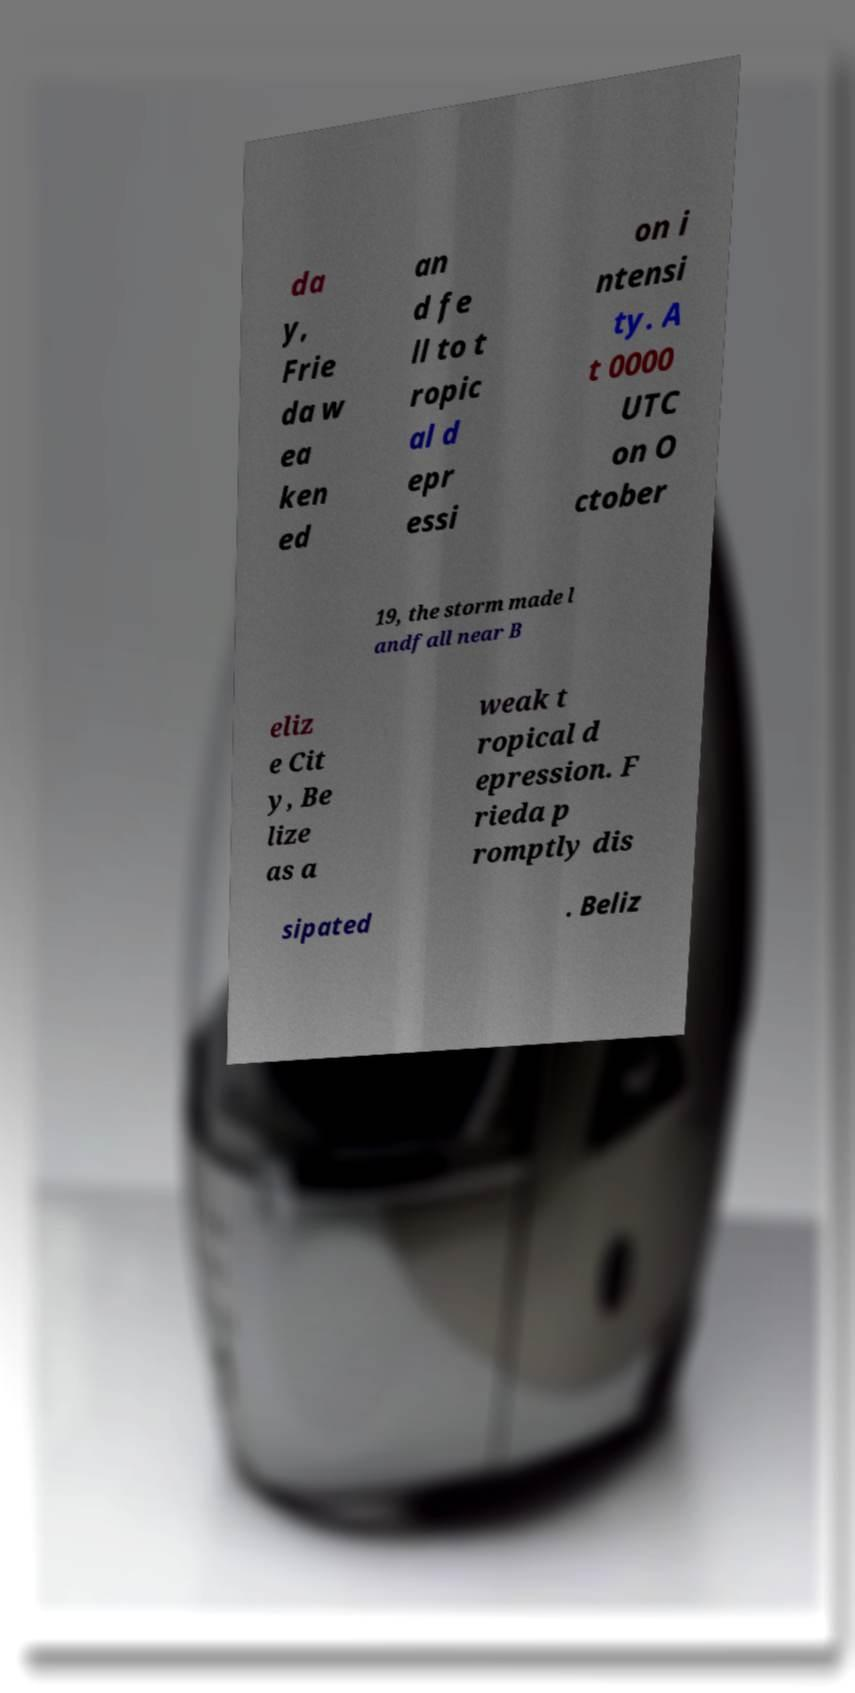I need the written content from this picture converted into text. Can you do that? da y, Frie da w ea ken ed an d fe ll to t ropic al d epr essi on i ntensi ty. A t 0000 UTC on O ctober 19, the storm made l andfall near B eliz e Cit y, Be lize as a weak t ropical d epression. F rieda p romptly dis sipated . Beliz 